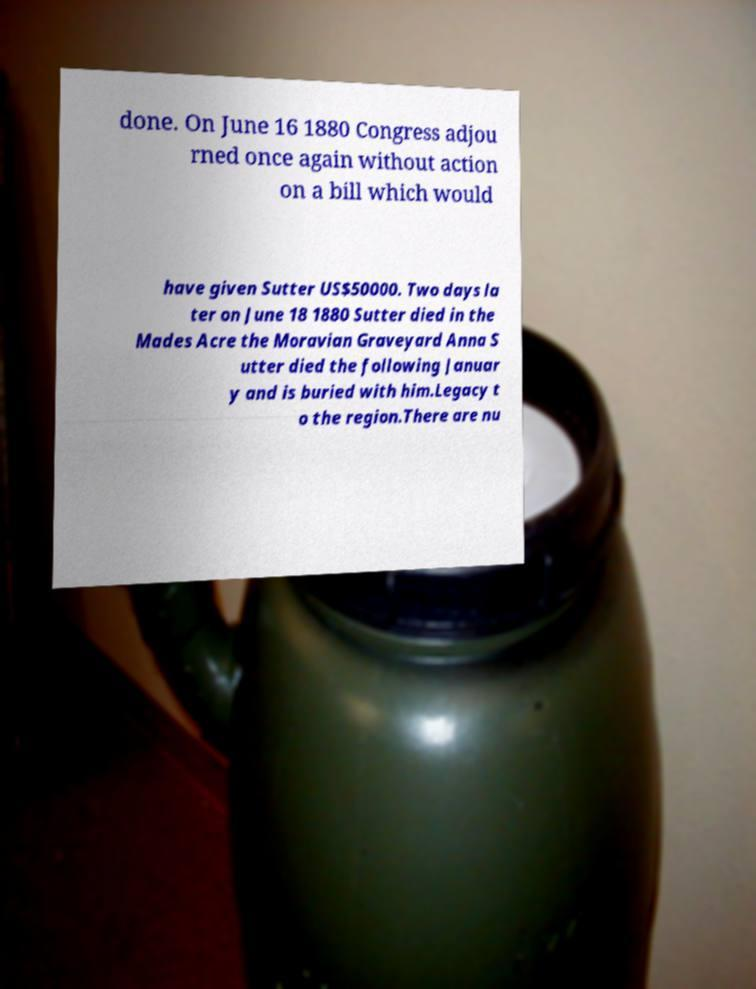Please read and relay the text visible in this image. What does it say? done. On June 16 1880 Congress adjou rned once again without action on a bill which would have given Sutter US$50000. Two days la ter on June 18 1880 Sutter died in the Mades Acre the Moravian Graveyard Anna S utter died the following Januar y and is buried with him.Legacy t o the region.There are nu 